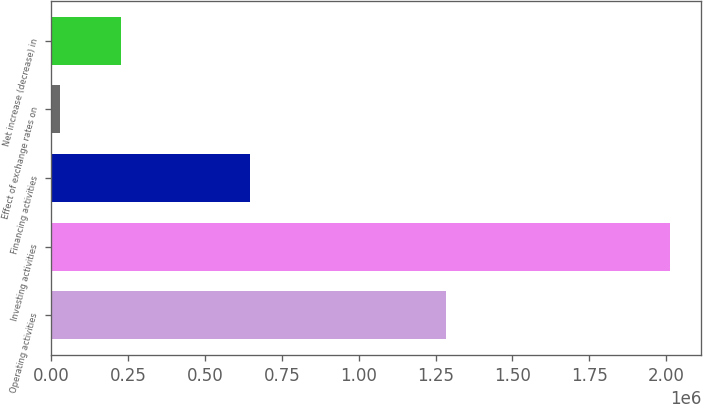Convert chart to OTSL. <chart><loc_0><loc_0><loc_500><loc_500><bar_chart><fcel>Operating activities<fcel>Investing activities<fcel>Financing activities<fcel>Effect of exchange rates on<fcel>Net increase (decrease) in<nl><fcel>1.28532e+06<fcel>2.01322e+06<fcel>647669<fcel>28768<fcel>227213<nl></chart> 